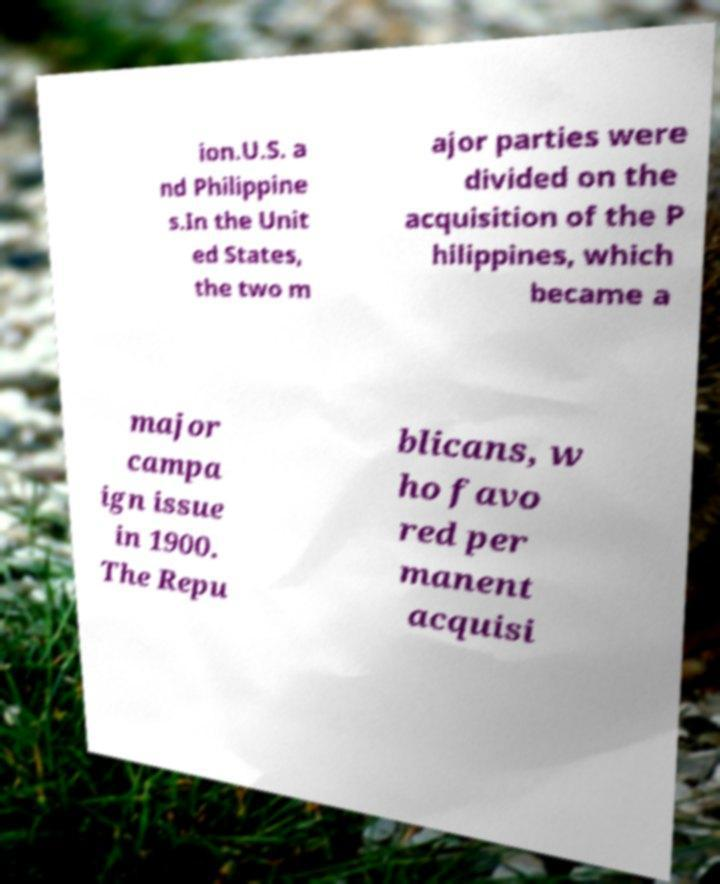Can you read and provide the text displayed in the image?This photo seems to have some interesting text. Can you extract and type it out for me? ion.U.S. a nd Philippine s.In the Unit ed States, the two m ajor parties were divided on the acquisition of the P hilippines, which became a major campa ign issue in 1900. The Repu blicans, w ho favo red per manent acquisi 